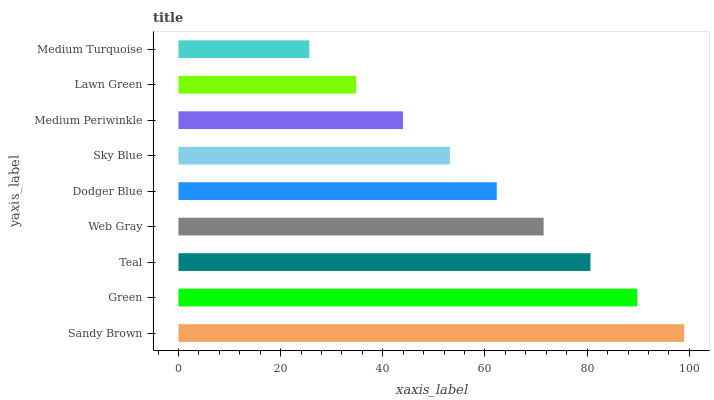Is Medium Turquoise the minimum?
Answer yes or no. Yes. Is Sandy Brown the maximum?
Answer yes or no. Yes. Is Green the minimum?
Answer yes or no. No. Is Green the maximum?
Answer yes or no. No. Is Sandy Brown greater than Green?
Answer yes or no. Yes. Is Green less than Sandy Brown?
Answer yes or no. Yes. Is Green greater than Sandy Brown?
Answer yes or no. No. Is Sandy Brown less than Green?
Answer yes or no. No. Is Dodger Blue the high median?
Answer yes or no. Yes. Is Dodger Blue the low median?
Answer yes or no. Yes. Is Green the high median?
Answer yes or no. No. Is Green the low median?
Answer yes or no. No. 